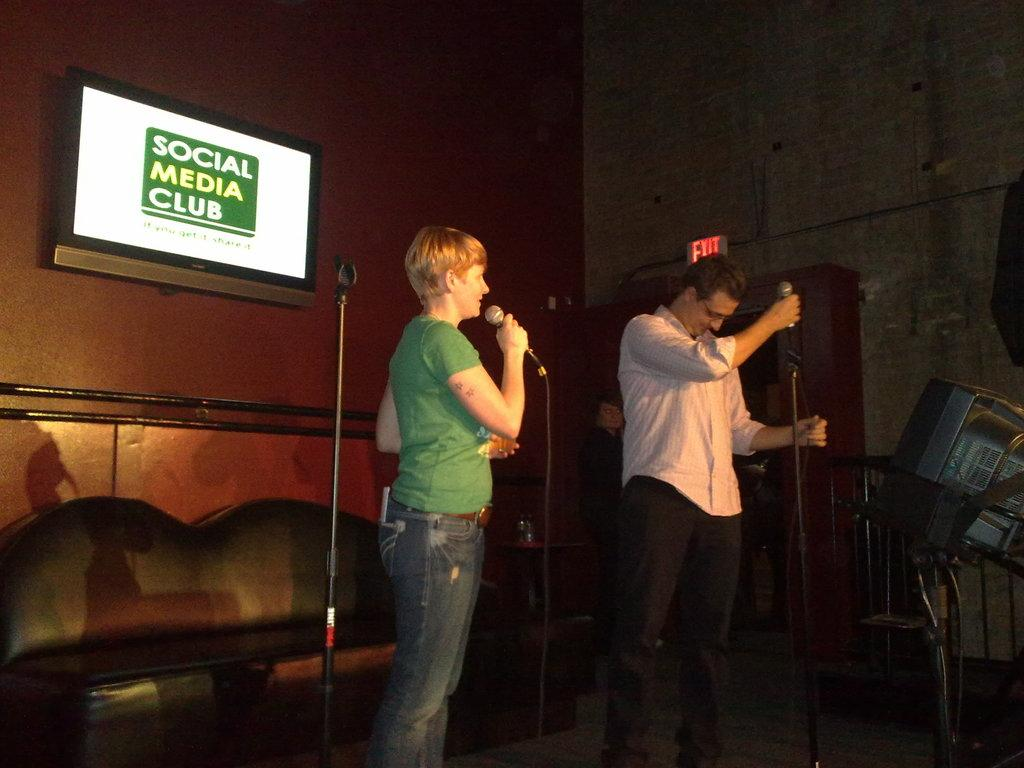What type of structure can be seen in the image? There is a wall in the image. What object is present on the wall? There is a tray in the image. What type of furniture is in the image? There is a bench in the image. What are the two people in the image doing? Two people are holding microphones in the image. Can you tell me how many grapes are on the bench in the image? There are no grapes present in the image; it features a wall, a tray, a bench, and two people holding microphones. What type of humor can be seen in the image? There is no humor depicted in the image; it is a straightforward scene with a wall, a tray, a bench, and two people holding microphones. 